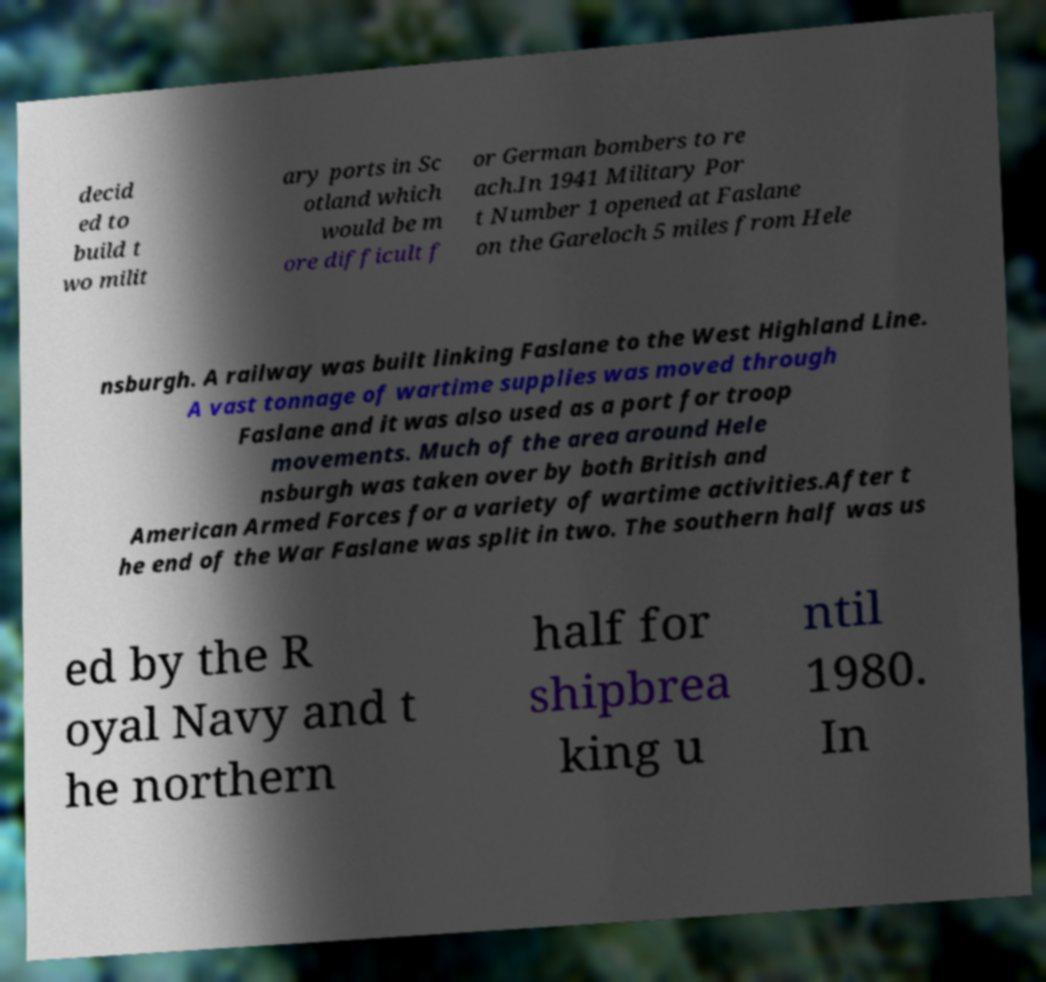There's text embedded in this image that I need extracted. Can you transcribe it verbatim? decid ed to build t wo milit ary ports in Sc otland which would be m ore difficult f or German bombers to re ach.In 1941 Military Por t Number 1 opened at Faslane on the Gareloch 5 miles from Hele nsburgh. A railway was built linking Faslane to the West Highland Line. A vast tonnage of wartime supplies was moved through Faslane and it was also used as a port for troop movements. Much of the area around Hele nsburgh was taken over by both British and American Armed Forces for a variety of wartime activities.After t he end of the War Faslane was split in two. The southern half was us ed by the R oyal Navy and t he northern half for shipbrea king u ntil 1980. In 